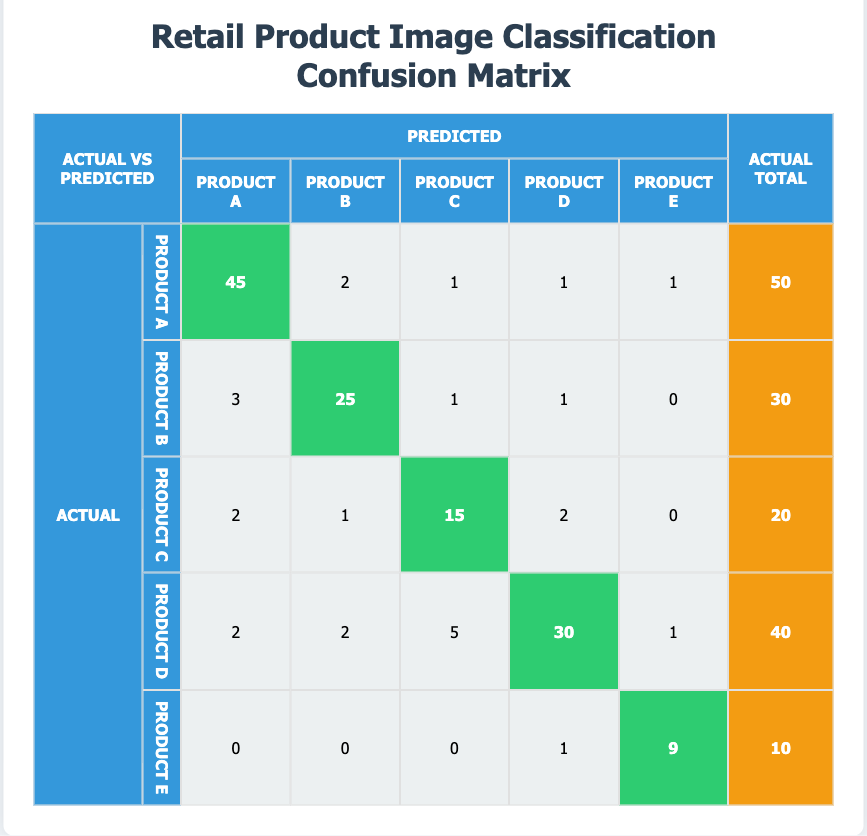What is the predicted value for Product A when the actual product is Product D? Referring to the row for Product D in the table, the predicted value for Product A is 2.
Answer: 2 How many total instances of Product B were predicted correctly? The correct predictions for Product B are in the diagonal cell, which has a value of 25.
Answer: 25 What is the total number of actual instances for Product C? Looking at the total for Product C, it is 20 (the last cell in the row).
Answer: 20 Is the number of incorrectly predicted instances for Product E greater than the number of correctly predicted instances? The correctly predicted instances for Product E are 9 (from the diagonal), while the incorrectly predicted instances are 1 (from Product D) plus 0 (from Product A, B, and C), totaling 1. Since 1 is less than 9, the statement is false.
Answer: No What is the overall total of all actual instances in the dataset? Sum the actual instances: 50 (A) + 30 (B) + 20 (C) + 40 (D) + 10 (E) = 150.
Answer: 150 Which product received the highest number of incorrect predictions? By examining the non-diagonal values in the rows, Product D has 2 (A) + 2 (B) + 5 (C) + 1 (E) = 10 incorrect predictions, which is higher than others.
Answer: Product D What is the average number of correctly predicted instances for all products? Calculate the correct predictions: 45 (A) + 25 (B) + 15 (C) + 30 (D) + 9 (E) = 124. There are 5 products, so the average is 124 / 5 = 24.8.
Answer: 24.8 How many misclassifications were made for Product A? The misclassifications for Product A are found by adding up the values in the Product A row, excluding the diagonal value: 2 + 1 + 1 + 1 = 5.
Answer: 5 Which product had the least number of instances predicted correctly? The least number of correctly predicted instances is for Product E, where the diagonal value is 9, which is less than all other diagonals.
Answer: Product E 